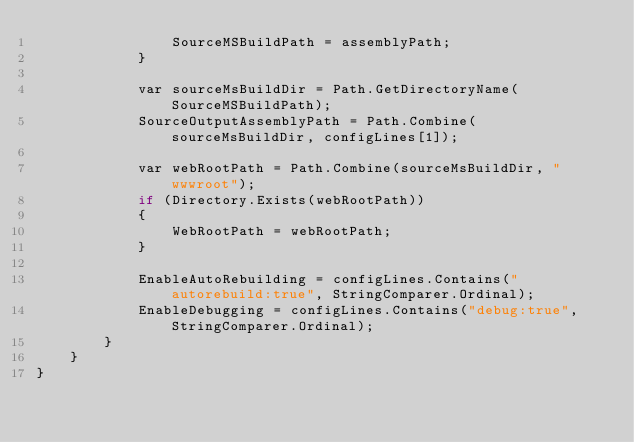Convert code to text. <code><loc_0><loc_0><loc_500><loc_500><_C#_>                SourceMSBuildPath = assemblyPath;
            }

            var sourceMsBuildDir = Path.GetDirectoryName(SourceMSBuildPath);
            SourceOutputAssemblyPath = Path.Combine(sourceMsBuildDir, configLines[1]);

            var webRootPath = Path.Combine(sourceMsBuildDir, "wwwroot");
            if (Directory.Exists(webRootPath))
            {
                WebRootPath = webRootPath;
            }

            EnableAutoRebuilding = configLines.Contains("autorebuild:true", StringComparer.Ordinal);
            EnableDebugging = configLines.Contains("debug:true", StringComparer.Ordinal);
        }
    }
}
</code> 